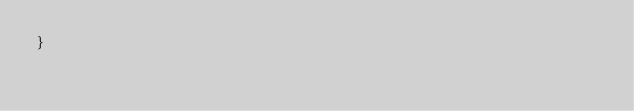<code> <loc_0><loc_0><loc_500><loc_500><_C_>}
</code> 